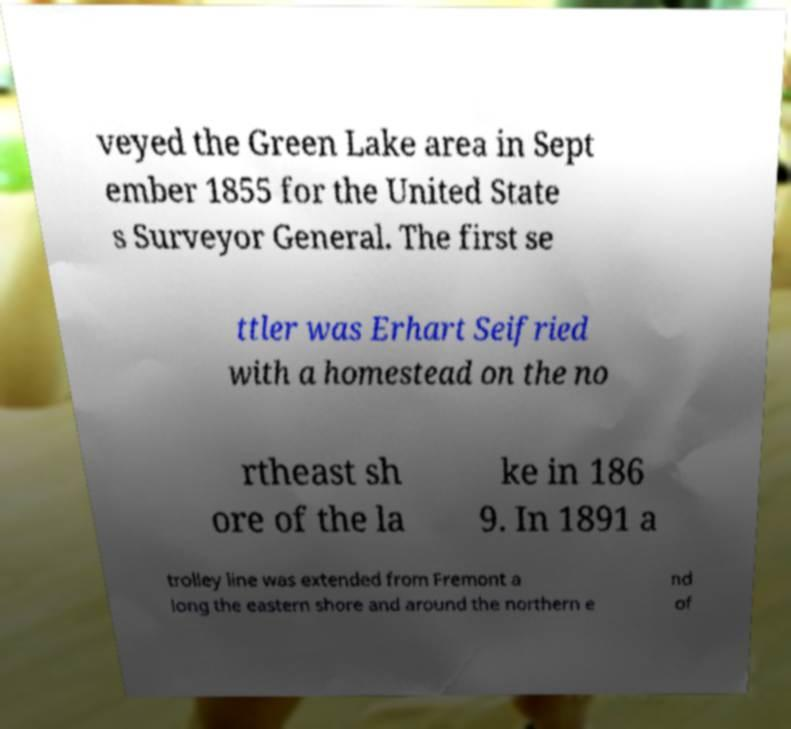Can you accurately transcribe the text from the provided image for me? veyed the Green Lake area in Sept ember 1855 for the United State s Surveyor General. The first se ttler was Erhart Seifried with a homestead on the no rtheast sh ore of the la ke in 186 9. In 1891 a trolley line was extended from Fremont a long the eastern shore and around the northern e nd of 